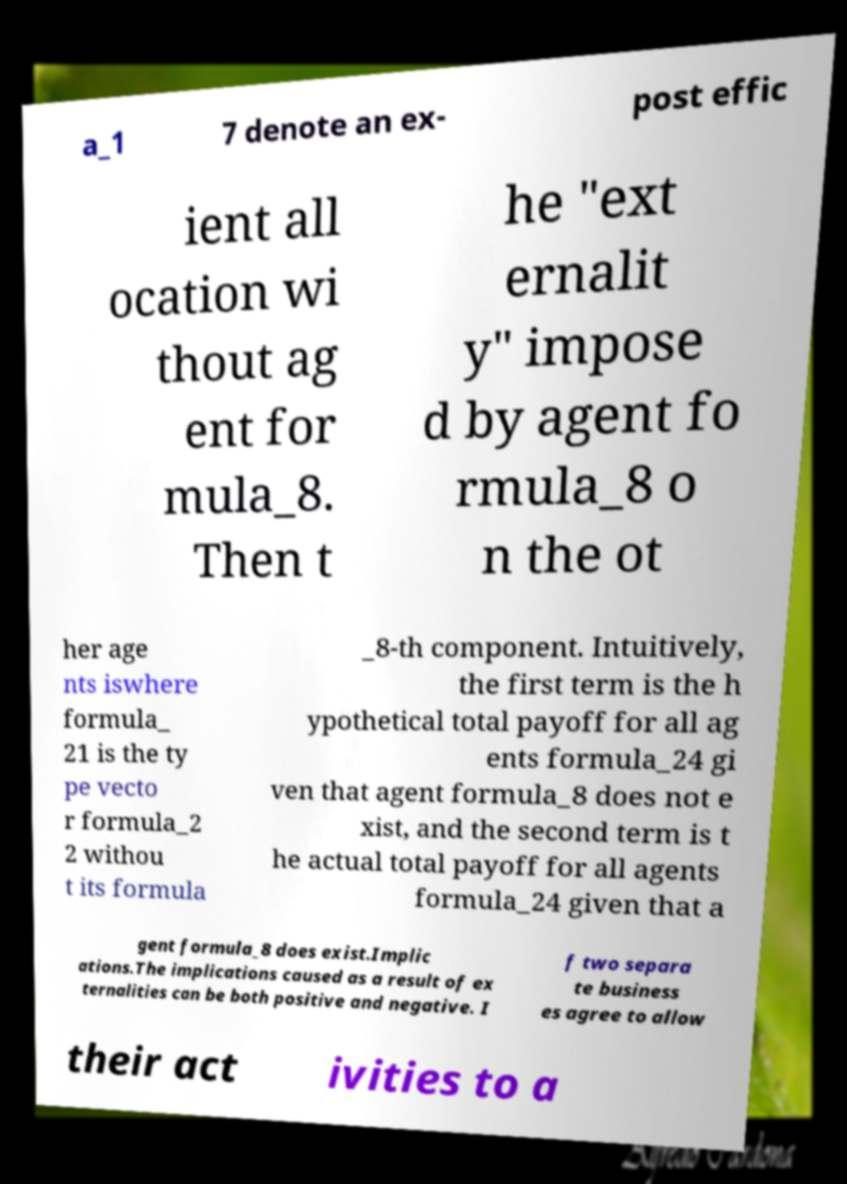Please identify and transcribe the text found in this image. a_1 7 denote an ex- post effic ient all ocation wi thout ag ent for mula_8. Then t he "ext ernalit y" impose d by agent fo rmula_8 o n the ot her age nts iswhere formula_ 21 is the ty pe vecto r formula_2 2 withou t its formula _8-th component. Intuitively, the first term is the h ypothetical total payoff for all ag ents formula_24 gi ven that agent formula_8 does not e xist, and the second term is t he actual total payoff for all agents formula_24 given that a gent formula_8 does exist.Implic ations.The implications caused as a result of ex ternalities can be both positive and negative. I f two separa te business es agree to allow their act ivities to a 